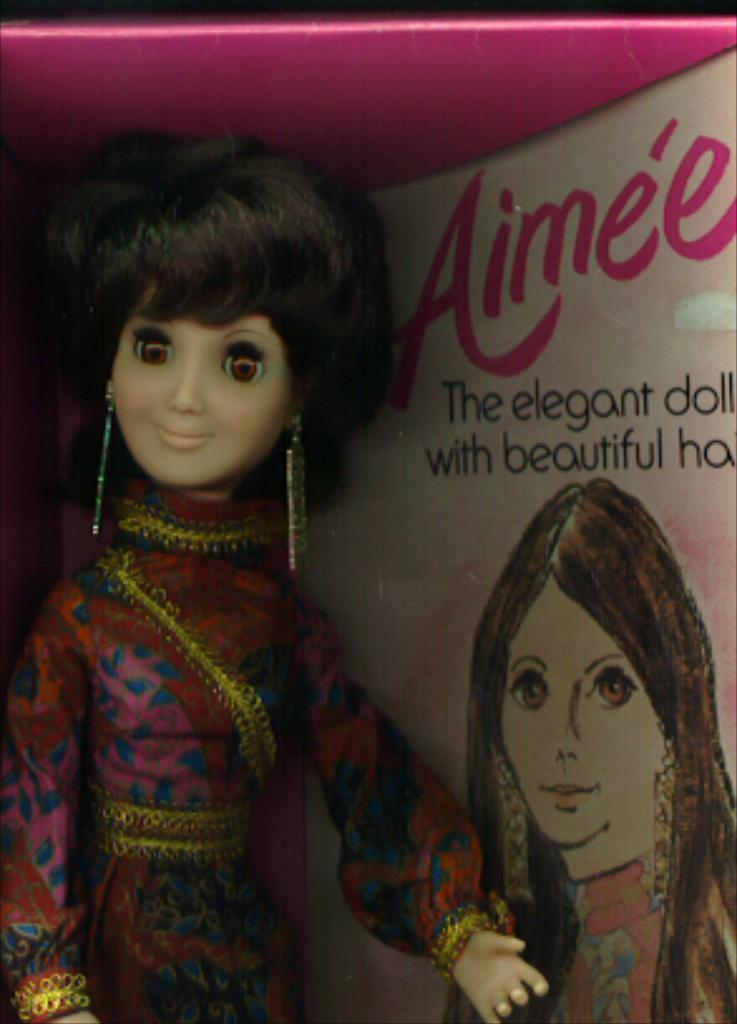What object is present in the image? There is a toy in the image. Where is the toy located? The toy is inside a box. What can be seen on the right side of the box? There is a picture drawn on the right side of the box and text written on it. What type of truck is visible in the image? There is no truck present in the image. What kind of apparatus is being used to draw the picture on the box? The facts do not mention any apparatus used to draw the picture on the box. Can you see a twig inside the box with the toy? There is no mention of a twig in the image, only the toy and the box with a picture and text on it. 